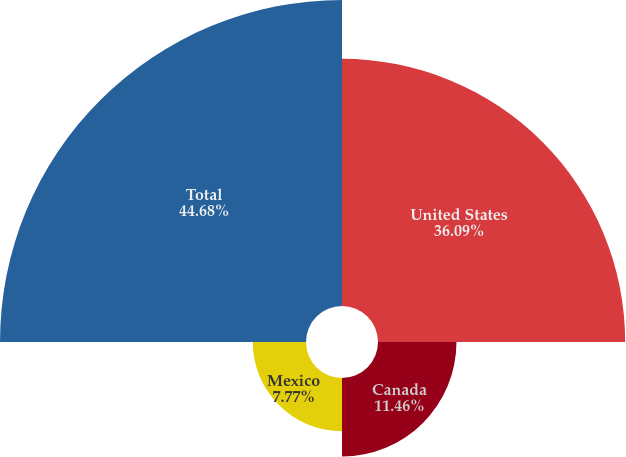Convert chart. <chart><loc_0><loc_0><loc_500><loc_500><pie_chart><fcel>United States<fcel>Canada<fcel>Mexico<fcel>Total<nl><fcel>36.09%<fcel>11.46%<fcel>7.77%<fcel>44.68%<nl></chart> 